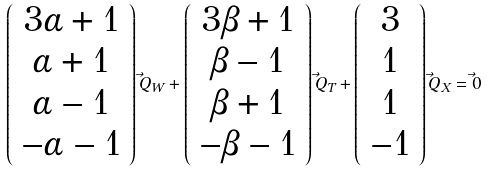Convert formula to latex. <formula><loc_0><loc_0><loc_500><loc_500>\left ( \begin{array} { c } 3 \alpha + 1 \\ \alpha + 1 \\ \alpha - 1 \\ - \alpha - 1 \end{array} \right ) \vec { Q } _ { W } + \left ( \begin{array} { c } 3 \beta + 1 \\ \beta - 1 \\ \beta + 1 \\ - \beta - 1 \end{array} \right ) \vec { Q } _ { T } + \left ( \begin{array} { c } 3 \\ 1 \\ 1 \\ - 1 \end{array} \right ) \vec { Q } _ { X } = \vec { 0 }</formula> 